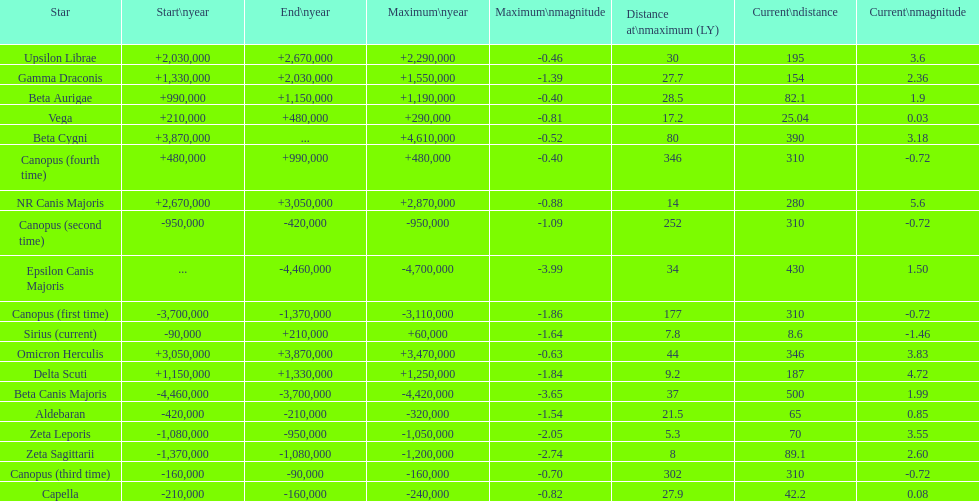How many stars do not have a current magnitude greater than zero? 5. 